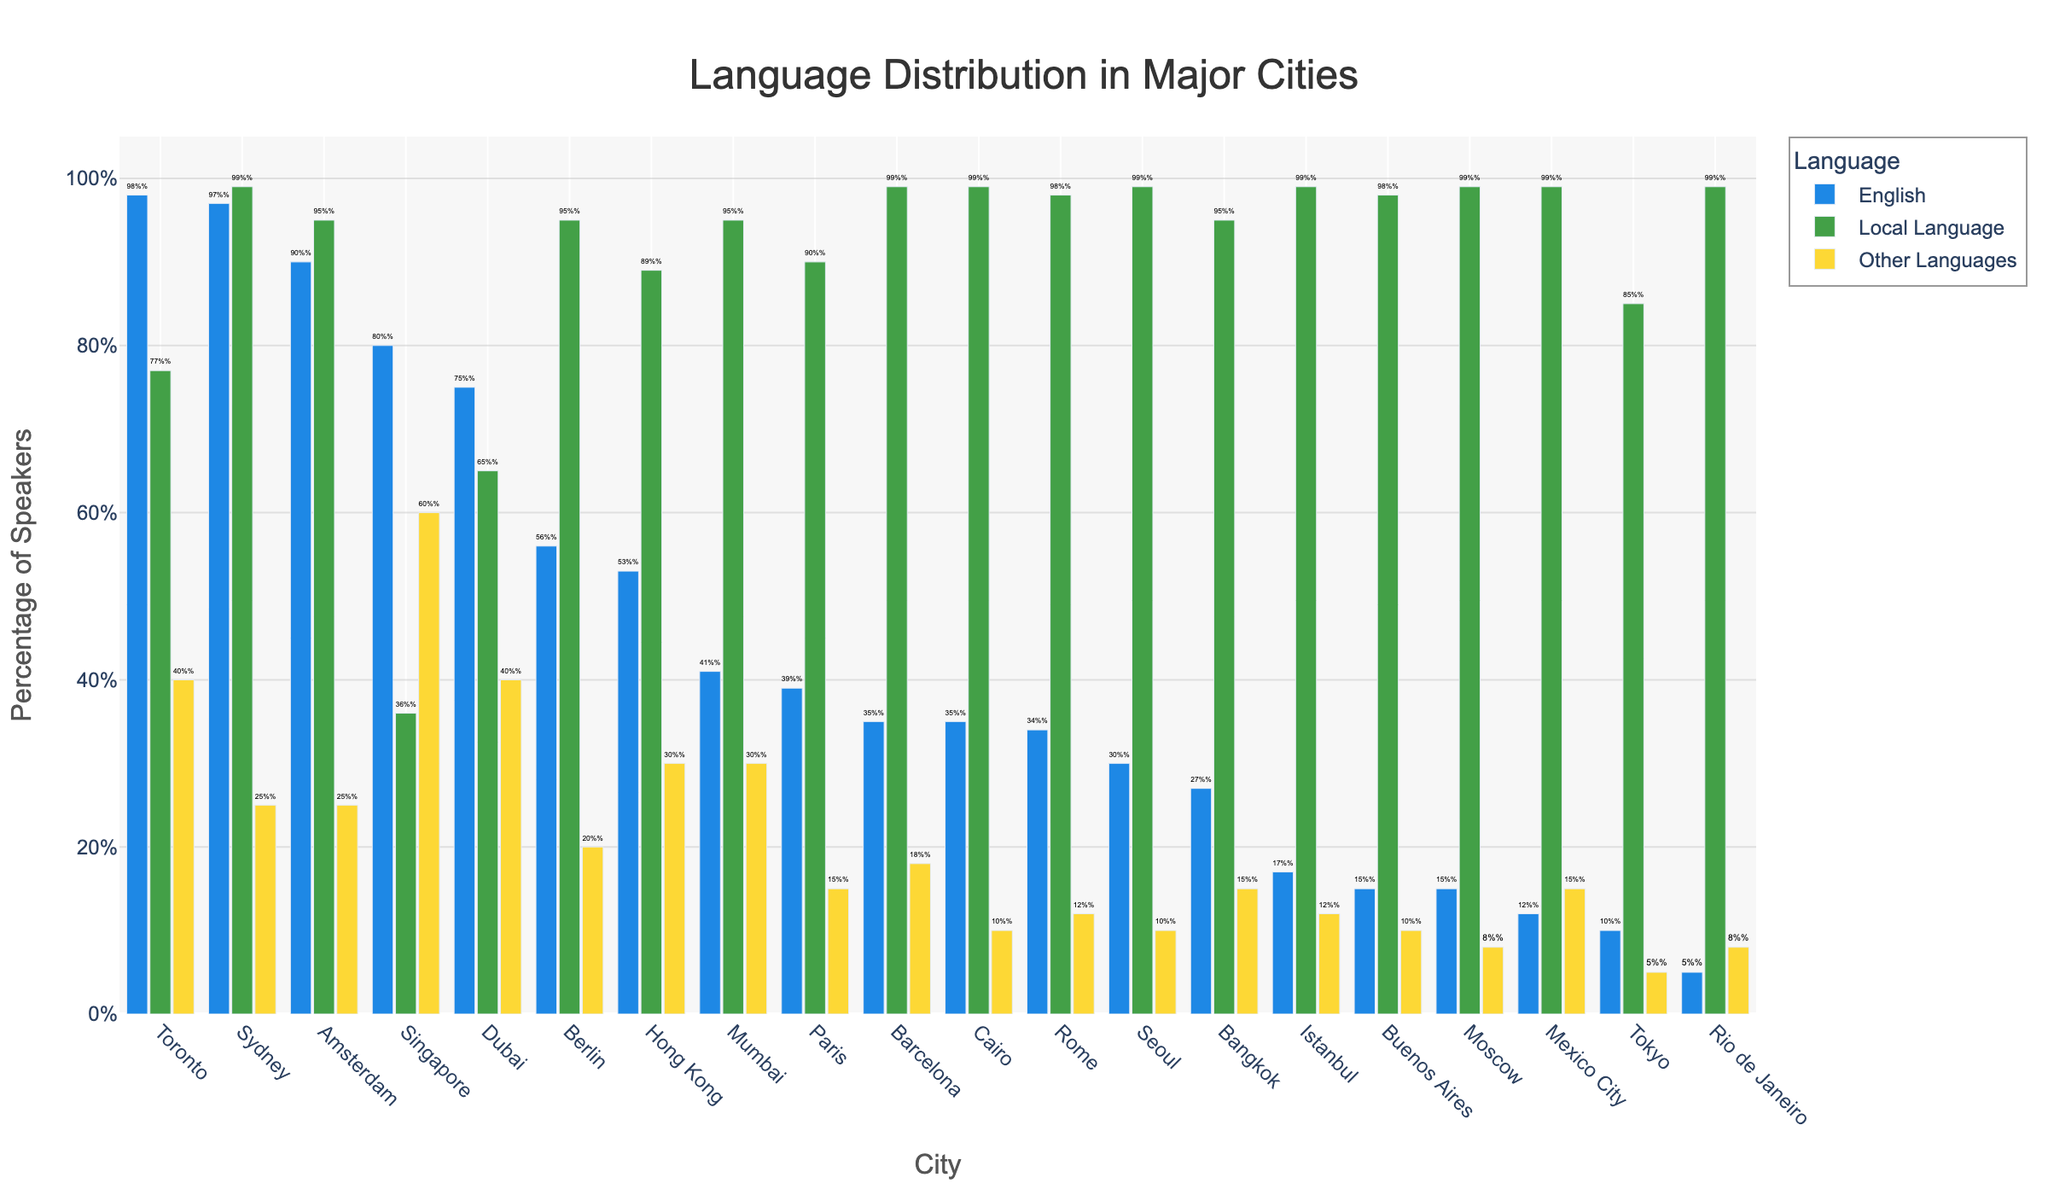Which city has the highest percentage of English speakers? Looking at the bar chart, we can see that Toronto has the highest bar for English speakers.
Answer: Toronto Which city has the smallest percentage of English speakers? The city with the shortest bar for English speakers in the chart is Rio de Janeiro.
Answer: Rio de Janeiro What is the difference in the percentage of English speakers between Toronto and Tokyo? Toronto has 98% English speakers, and Tokyo has 10% English speakers. The difference is 98% - 10% = 88%.
Answer: 88% Which cities have a higher percentage of English speakers than local language speakers? By comparing the bars for English and local languages, only Singapore fits, where English bars are higher than local language bars.
Answer: Singapore How many cities have more than 50% English speakers? The bars for English speakers exceed the 50% mark for Berlin, Amsterdam, Dubai, Singapore, Hong Kong, Sydney, and Toronto.
Answer: 7 What is the average percentage of English speakers in Paris, Rome, and Istanbul? The percentages are Paris (39%), Rome (34%), and Istanbul (17%). The average is (39% + 34% + 17%) / 3 = 30%.
Answer: 30% Which city has the highest percentage of speakers of "Other Languages"? Toronto and Singapore both have the highest bar for "Other Languages", with a percentage of 40%.
Answer: Toronto and Singapore What is the sum of percentage of local language speakers in Mumbai and Berlin? The local language percentages are Mumbai (95%) and Berlin (95%). Their sum is 95% + 95% = 190%.
Answer: 190% Which city has the closest percentage of English and local language speakers? Tokyo has English speakers at 10% and local language speakers at 85%, showing a big gap. Paris, with English at 39% and local language at 90%, has a closer match. But the closest is in cumulative cities like Dubai and Singapore, where Dubai has English at 75% and local at 65%, with a close 10% difference.
Answer: Dubai 